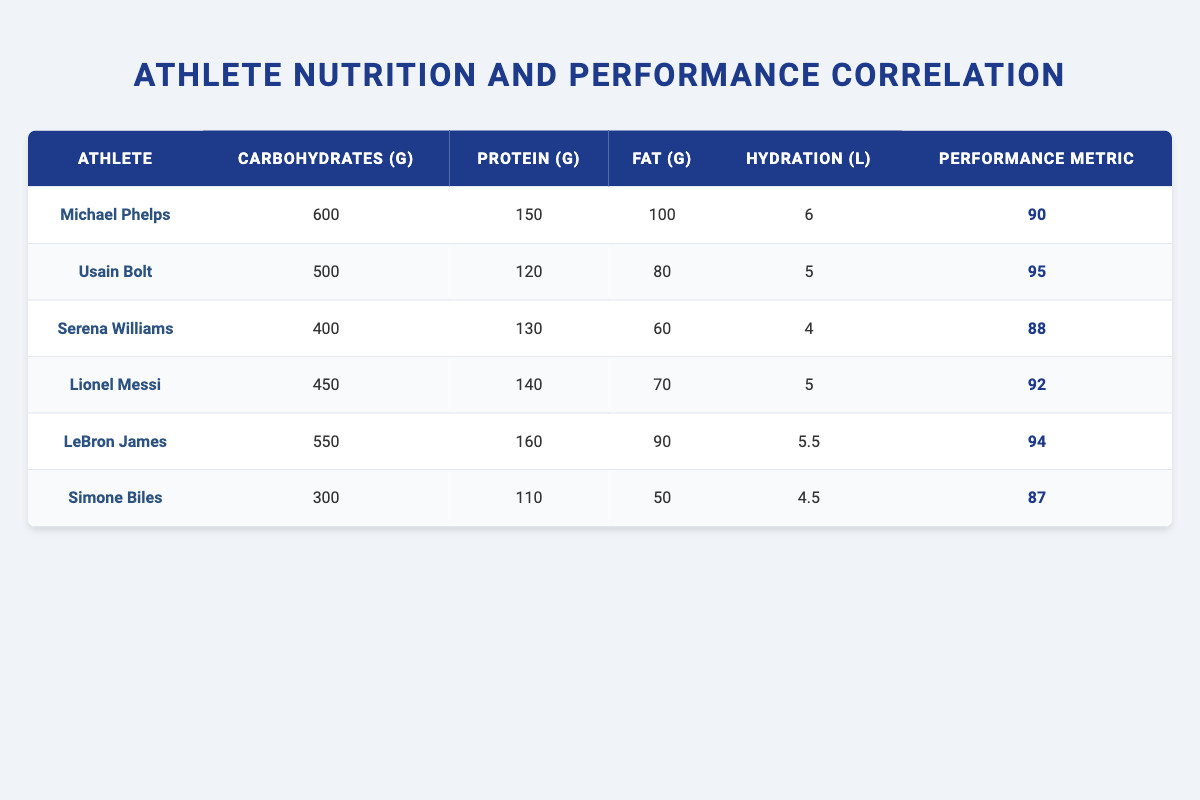What is the carbohydrate intake of Usain Bolt? In the table, under Usain Bolt's row, the carbohydrate intake is listed as 500 grams.
Answer: 500 g Which athlete has the highest protein intake? By examining the protein intake values from all athletes, LeBron James has the highest protein intake of 160 grams.
Answer: 160 g Is it true that Serena Williams has a higher performance metric than Simone Biles? Serena Williams has a performance metric of 88, while Simone Biles has a metric of 87. Since 88 is greater than 87, the statement is true.
Answer: Yes What is the average fat intake among all athletes? The fat intakes are: 100, 80, 60, 70, 90, and 50 grams. Adding these gives a total of 450 grams. There are 6 athletes, so the average is 450/6 = 75 grams.
Answer: 75 g How many liters of hydration does Michael Phelps need compared to the average of all athletes? Michael Phelps requires 6 liters of hydration. The average hydration of all athletes can be calculated by totaling: 6 + 5 + 4 + 5 + 5.5 + 4.5 = 30 and dividing by 6, which equals 5 liters. Since 6 is greater than 5, Michael Phelps needs more hydration than average.
Answer: More Which athlete has the lowest performance metric? Reviewing the performance metrics, Simone Biles has the lowest at 87.
Answer: 87 